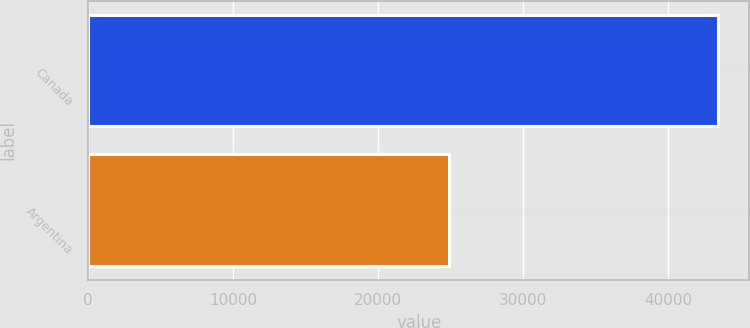Convert chart. <chart><loc_0><loc_0><loc_500><loc_500><bar_chart><fcel>Canada<fcel>Argentina<nl><fcel>43437<fcel>24893<nl></chart> 